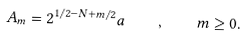Convert formula to latex. <formula><loc_0><loc_0><loc_500><loc_500>A _ { m } = 2 ^ { 1 / 2 - N + m / 2 } a \quad , \quad m \geq 0 .</formula> 